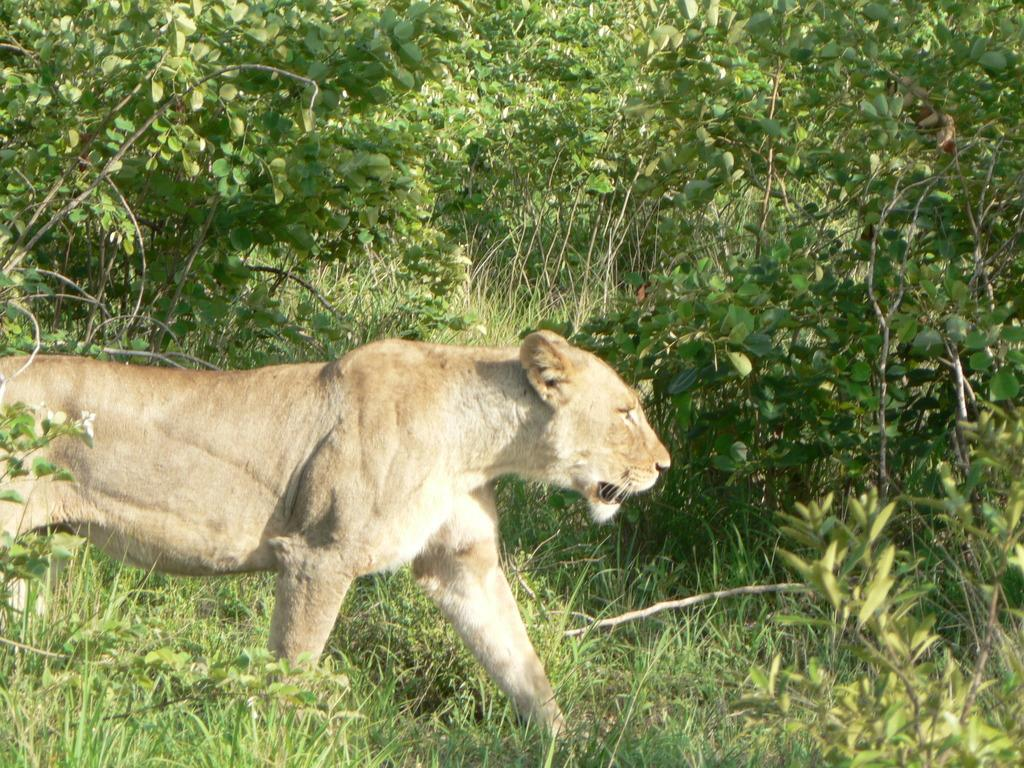What type of vegetation can be seen on the ground in the image? There is green grass on the ground in the image. What other green objects are present in the image? There are green color plants in the image. Where is the tiger located in the image? The tiger is on the left side of the image. Can you tell me how many cacti are present in the image? There are no cacti present in the image; it features green grass and plants. What type of ring can be seen on the tiger's paw in the image? There is no ring present on the tiger's paw in the image. 